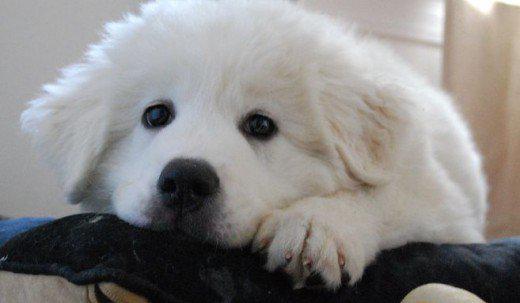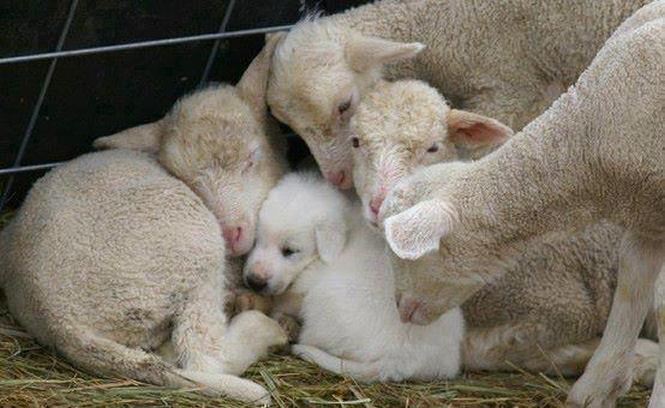The first image is the image on the left, the second image is the image on the right. Assess this claim about the two images: "One of the pictures shows a puppy sleeping alone.". Correct or not? Answer yes or no. No. The first image is the image on the left, the second image is the image on the right. Given the left and right images, does the statement "One image shows a single reclining white puppy with at least one front paw forward, and the other image shows a white dog reclining with a 'real' sleeping hooved animal." hold true? Answer yes or no. Yes. 